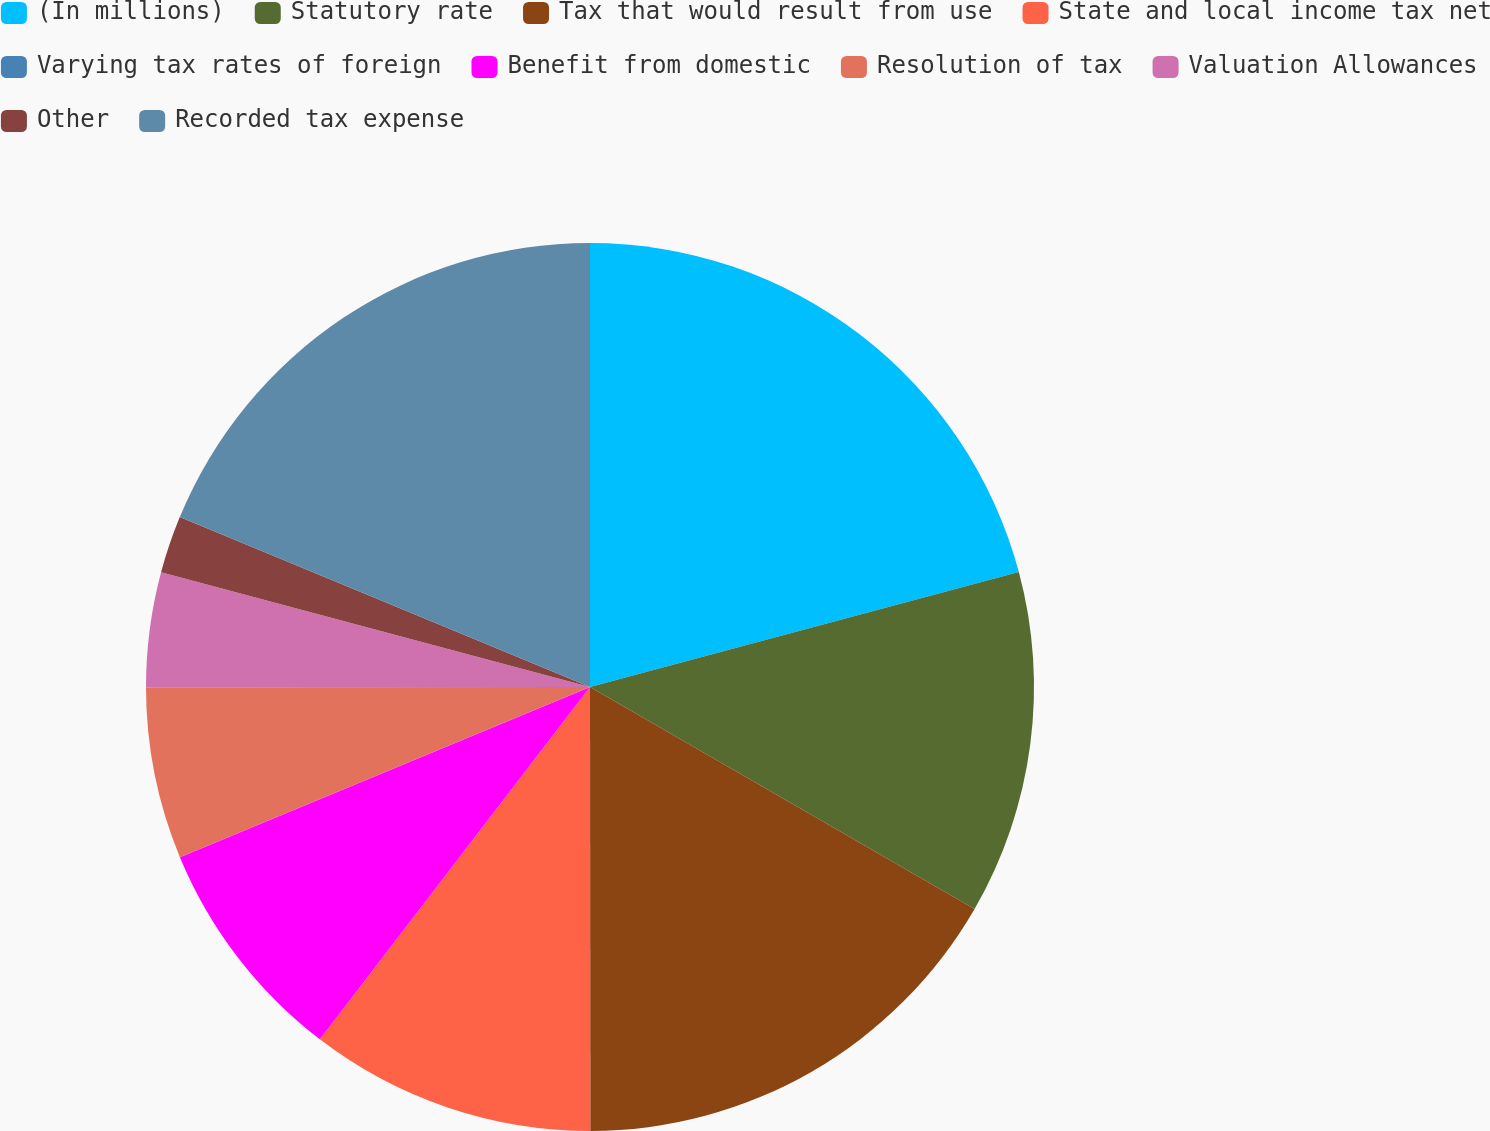<chart> <loc_0><loc_0><loc_500><loc_500><pie_chart><fcel>(In millions)<fcel>Statutory rate<fcel>Tax that would result from use<fcel>State and local income tax net<fcel>Varying tax rates of foreign<fcel>Benefit from domestic<fcel>Resolution of tax<fcel>Valuation Allowances<fcel>Other<fcel>Recorded tax expense<nl><fcel>20.83%<fcel>12.5%<fcel>16.66%<fcel>10.42%<fcel>0.0%<fcel>8.33%<fcel>6.25%<fcel>4.17%<fcel>2.09%<fcel>18.75%<nl></chart> 